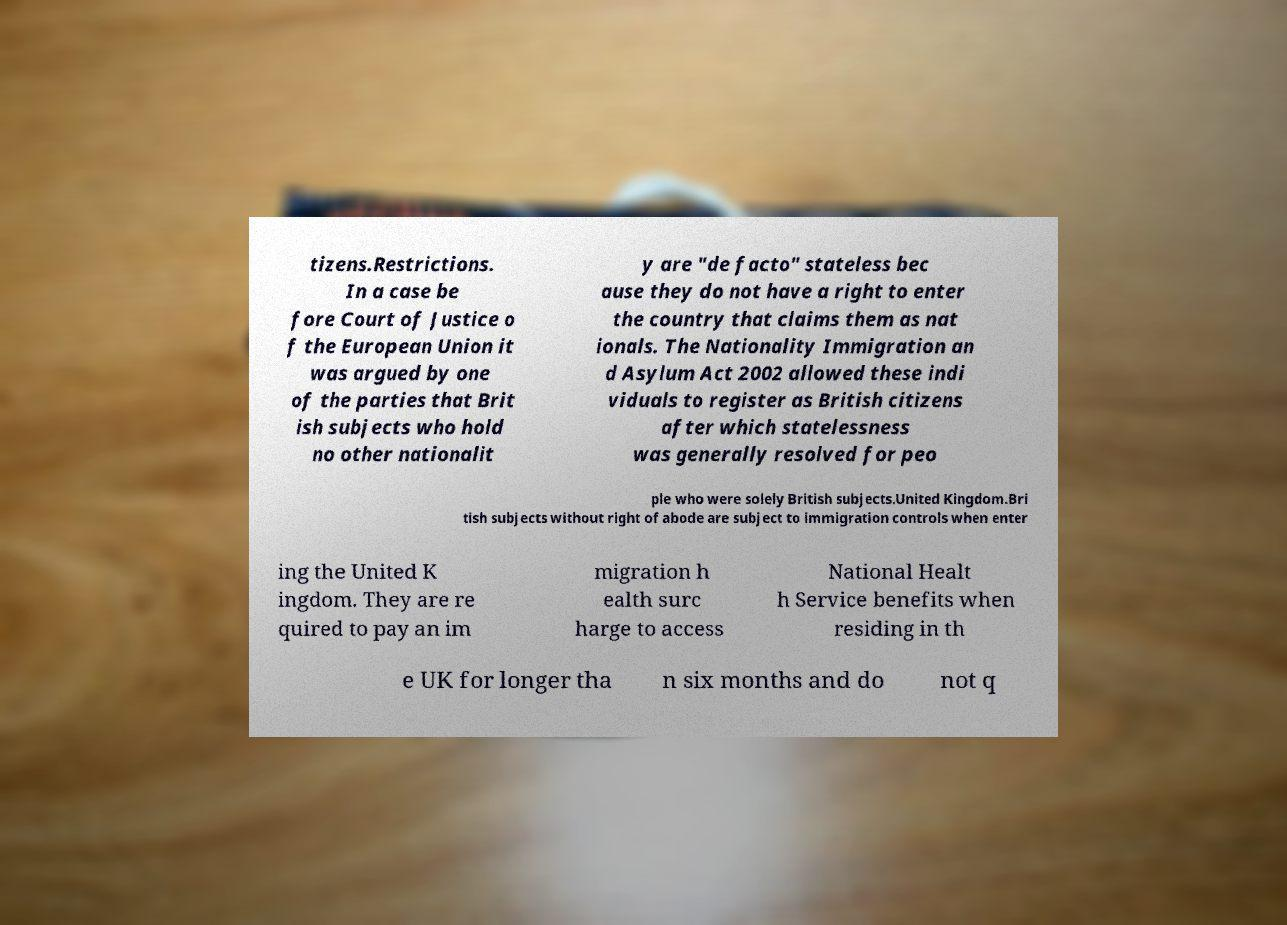For documentation purposes, I need the text within this image transcribed. Could you provide that? tizens.Restrictions. In a case be fore Court of Justice o f the European Union it was argued by one of the parties that Brit ish subjects who hold no other nationalit y are "de facto" stateless bec ause they do not have a right to enter the country that claims them as nat ionals. The Nationality Immigration an d Asylum Act 2002 allowed these indi viduals to register as British citizens after which statelessness was generally resolved for peo ple who were solely British subjects.United Kingdom.Bri tish subjects without right of abode are subject to immigration controls when enter ing the United K ingdom. They are re quired to pay an im migration h ealth surc harge to access National Healt h Service benefits when residing in th e UK for longer tha n six months and do not q 